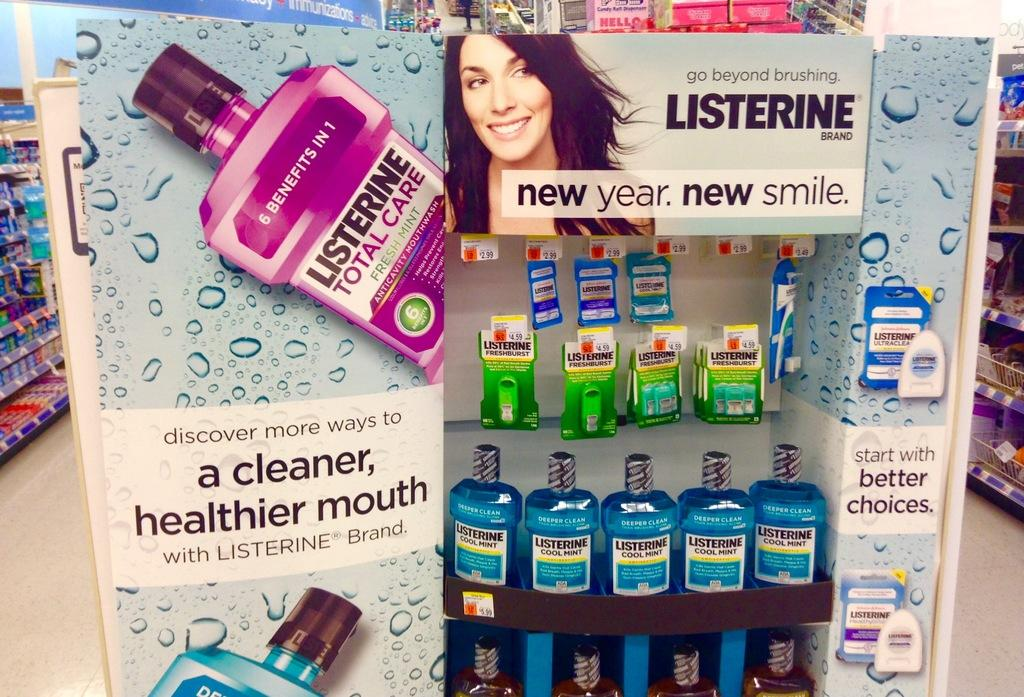<image>
Write a terse but informative summary of the picture. A display stand advertising Listerine mouthwash with the slogan 'new year, new smile.' 